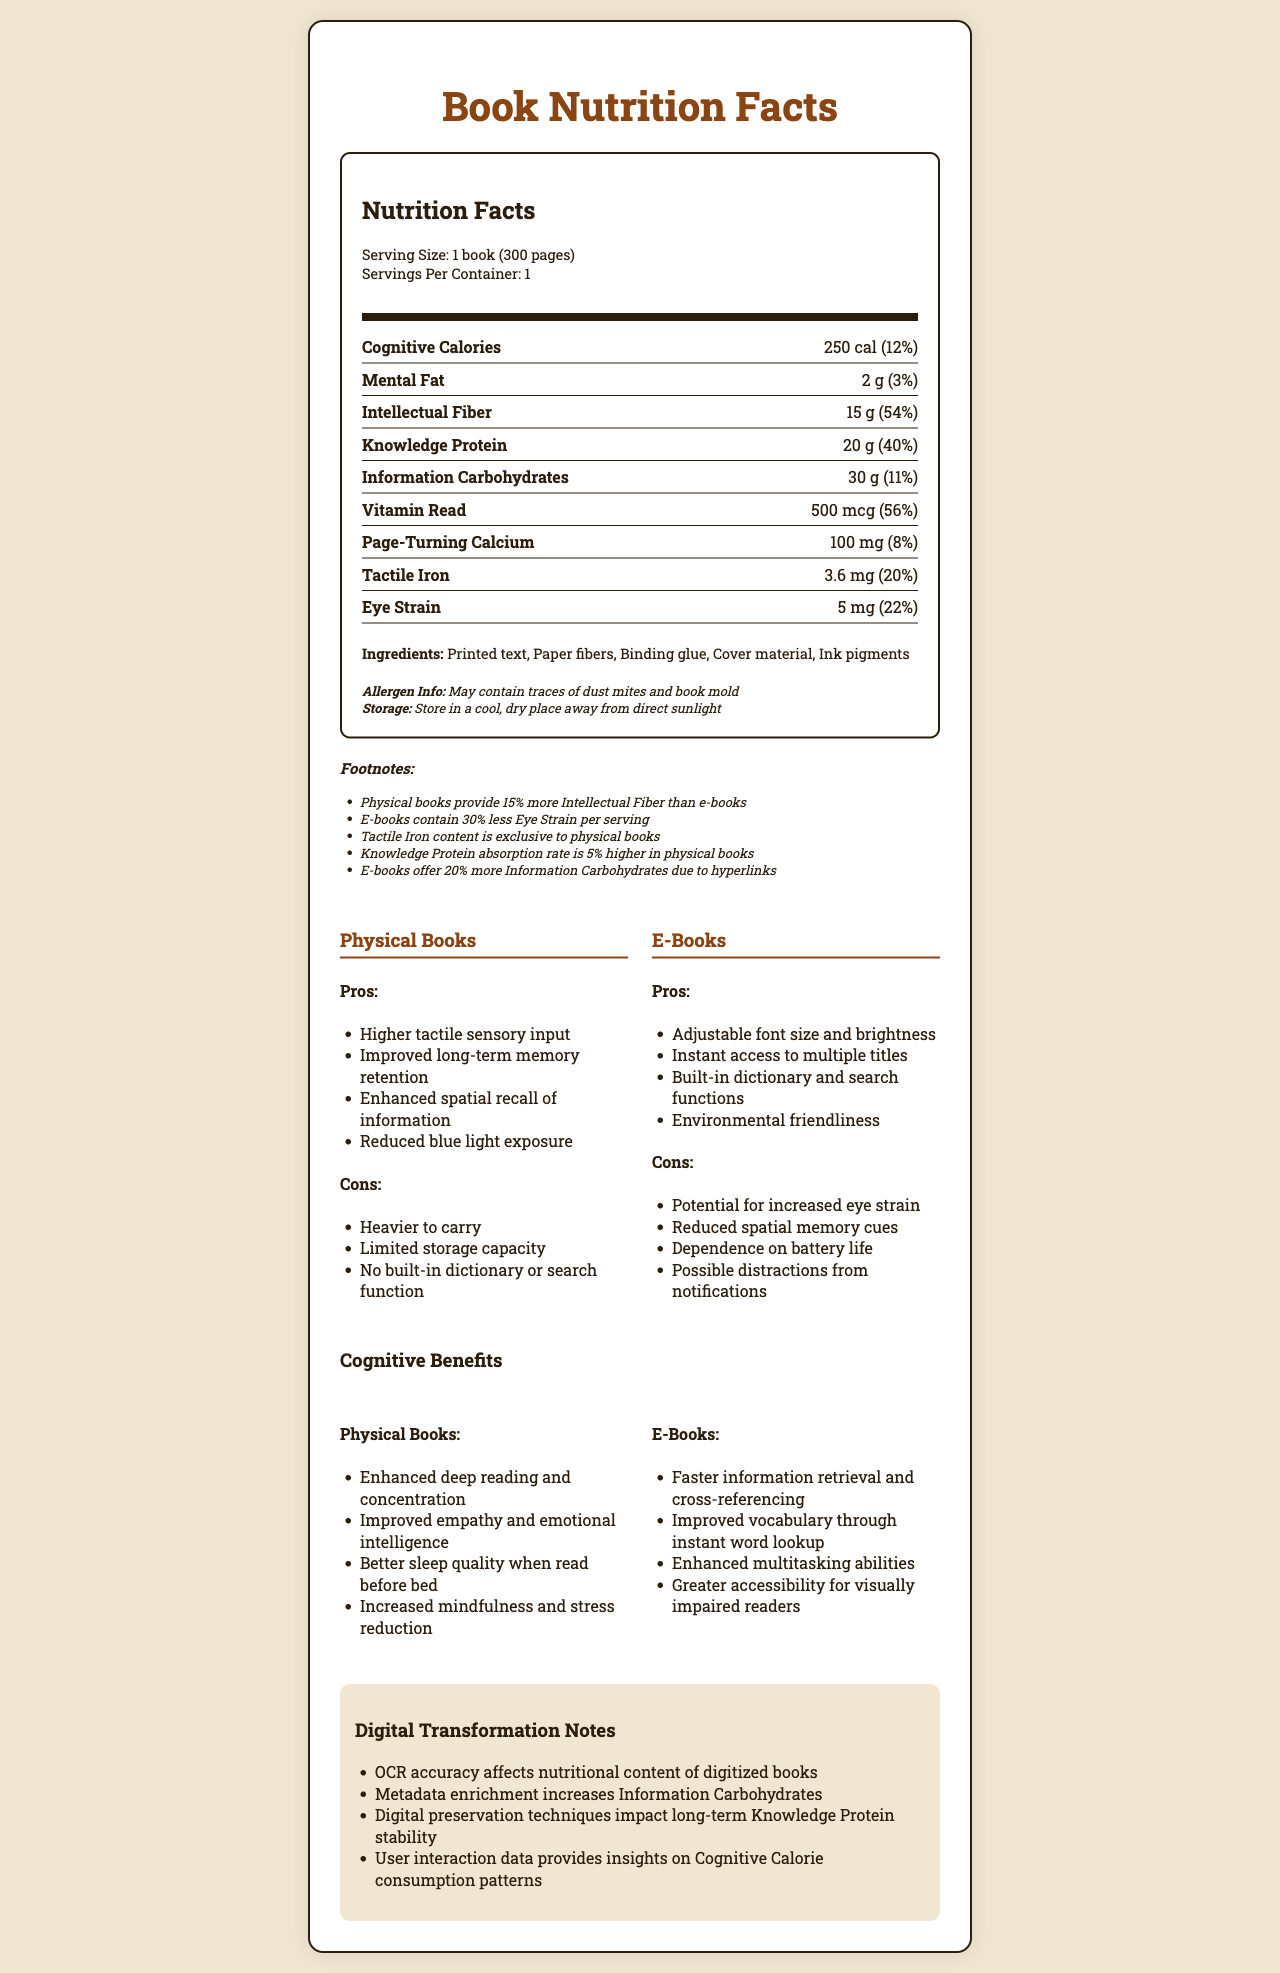what is the serving size of a physical book? The serving size is shown at the beginning of the nutrition facts section as 1 book (300 pages).
Answer: 1 book (300 pages) How much Cognitive Calories does a physical book provide? The Cognitive Calories amount is listed as 250 cal in the nutrient row section.
Answer: 250 cal What ingredients are found in physical books? The ingredients are listed in a section titled "Ingredients" within the document.
Answer: Printed text, Paper fibers, Binding glue, Cover material, Ink pigments What are the storage instructions for physical books? The storage instructions are clearly mentioned below the allergen info section.
Answer: Store in a cool, dry place away from direct sunlight How much Mental Fat is present in one serving of a physical book? The amount of Mental Fat is indicated as 2 g in the nutrient row section.
Answer: 2 g What is one advantage of e-books related to readability? A. Increased long-term memory retention B. Adjustable font size and brightness C. Reduced chances of book mold D. Enhanced deep reading and concentration The pros of e-books list "Adjustable font size and brightness" as one of their advantages.
Answer: B Which nutrient is exclusive to physical books? A. Knowledge Protein B. Tactile Iron C. Eye Strain D. Information Carbohydrates The footnotes section specifies that Tactile Iron content is exclusive to physical books.
Answer: B Do e-books provide better sleep quality than physical books when read before bed? One of the cognitive benefits of physical books listed is "Better sleep quality when read before bed."
Answer: No Summarize the main differences between physical books and e-books mentioned in the document. Physical books are noted for their sensory and memory benefits, while e-books are valued for their convenience and adjustability. Each has specific pros and cons, such as weight and potential distractions for e-books.
Answer: Physical books offer higher tactile sensory input and improved memory retention but are heavier and have less storage capacity. E-books provide instant access to multiple titles and customizable readability features but may lead to more eye strain and depend on battery life. Is there enough information in the document to determine how much Vitamin Read e-books contain? The document only provides the nutritional content for physical books; it does not specify the Vitamin Read content for e-books.
Answer: No 